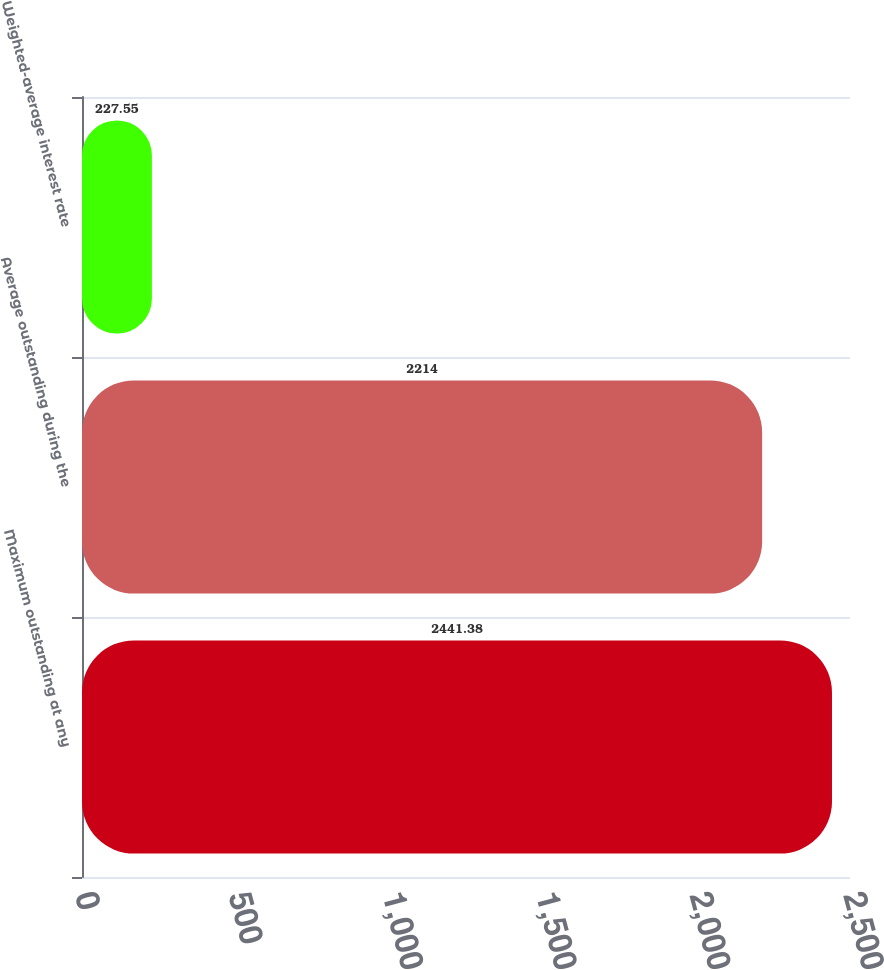<chart> <loc_0><loc_0><loc_500><loc_500><bar_chart><fcel>Maximum outstanding at any<fcel>Average outstanding during the<fcel>Weighted-average interest rate<nl><fcel>2441.38<fcel>2214<fcel>227.55<nl></chart> 